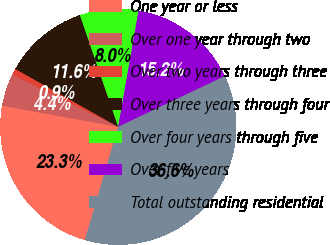<chart> <loc_0><loc_0><loc_500><loc_500><pie_chart><fcel>One year or less<fcel>Over one year through two<fcel>Over two years through three<fcel>Over three years through four<fcel>Over four years through five<fcel>Over five years<fcel>Total outstanding residential<nl><fcel>23.3%<fcel>4.44%<fcel>0.86%<fcel>11.59%<fcel>8.01%<fcel>15.17%<fcel>36.63%<nl></chart> 